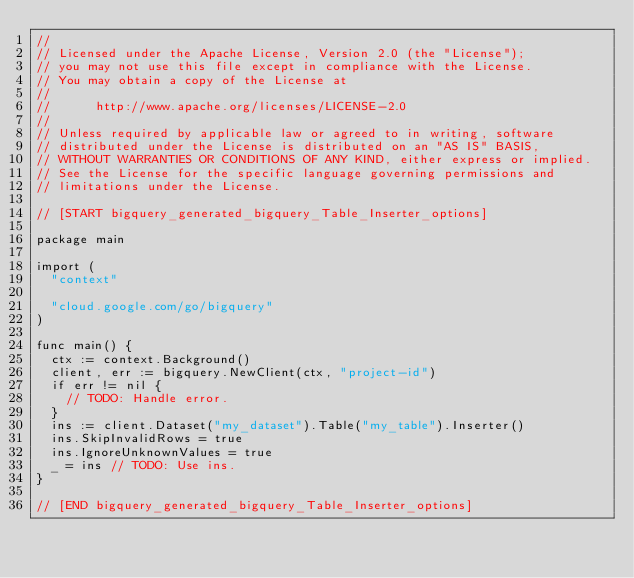<code> <loc_0><loc_0><loc_500><loc_500><_Go_>//
// Licensed under the Apache License, Version 2.0 (the "License");
// you may not use this file except in compliance with the License.
// You may obtain a copy of the License at
//
//      http://www.apache.org/licenses/LICENSE-2.0
//
// Unless required by applicable law or agreed to in writing, software
// distributed under the License is distributed on an "AS IS" BASIS,
// WITHOUT WARRANTIES OR CONDITIONS OF ANY KIND, either express or implied.
// See the License for the specific language governing permissions and
// limitations under the License.

// [START bigquery_generated_bigquery_Table_Inserter_options]

package main

import (
	"context"

	"cloud.google.com/go/bigquery"
)

func main() {
	ctx := context.Background()
	client, err := bigquery.NewClient(ctx, "project-id")
	if err != nil {
		// TODO: Handle error.
	}
	ins := client.Dataset("my_dataset").Table("my_table").Inserter()
	ins.SkipInvalidRows = true
	ins.IgnoreUnknownValues = true
	_ = ins // TODO: Use ins.
}

// [END bigquery_generated_bigquery_Table_Inserter_options]
</code> 